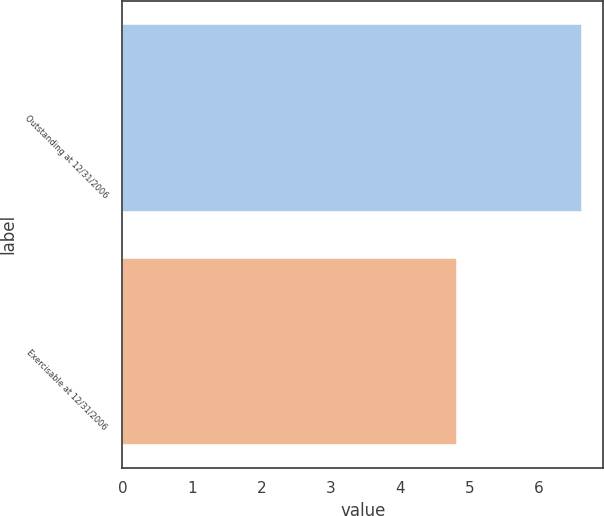Convert chart. <chart><loc_0><loc_0><loc_500><loc_500><bar_chart><fcel>Outstanding at 12/31/2006<fcel>Exercisable at 12/31/2006<nl><fcel>6.6<fcel>4.8<nl></chart> 